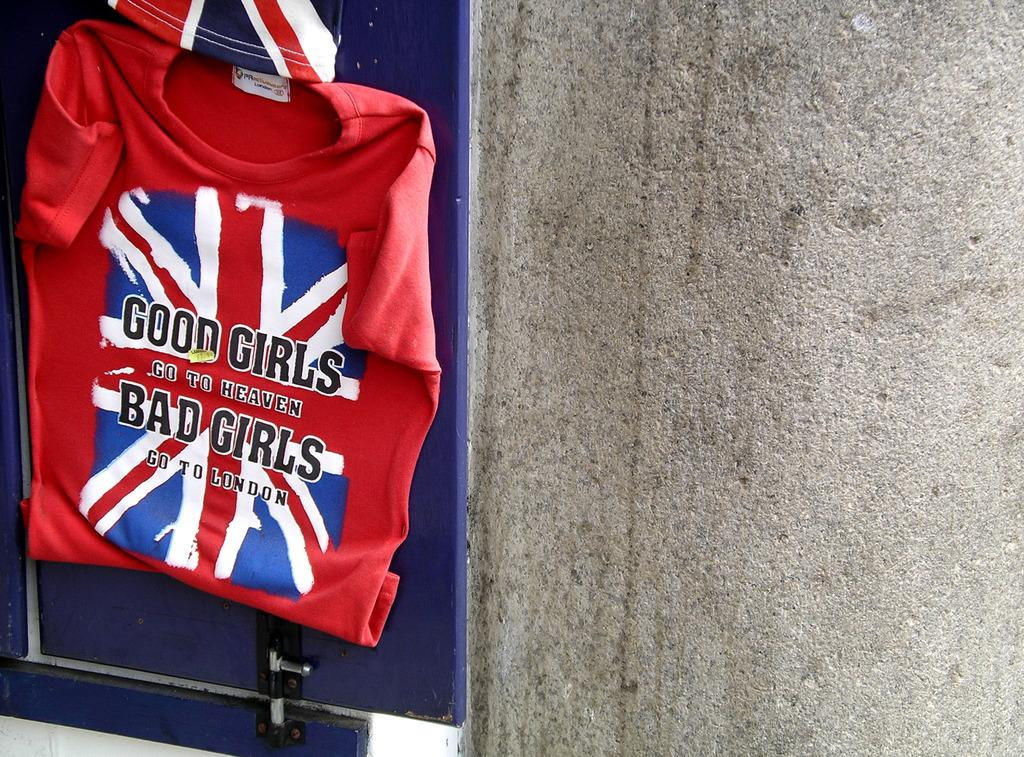<image>
Provide a brief description of the given image. a Bad Girls saying on a red piece of cloth 